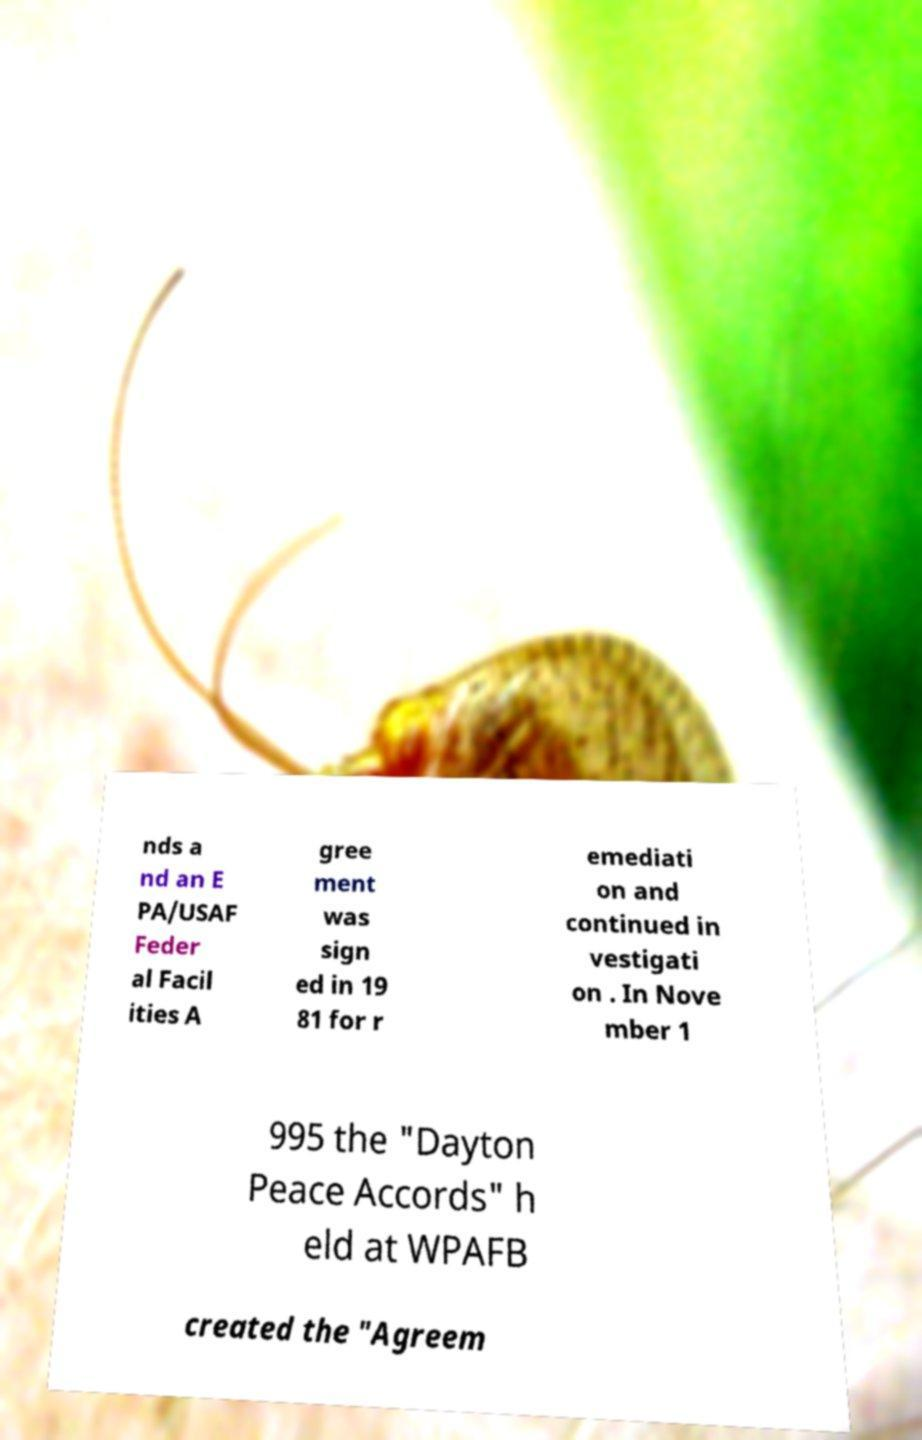Can you read and provide the text displayed in the image?This photo seems to have some interesting text. Can you extract and type it out for me? nds a nd an E PA/USAF Feder al Facil ities A gree ment was sign ed in 19 81 for r emediati on and continued in vestigati on . In Nove mber 1 995 the "Dayton Peace Accords" h eld at WPAFB created the "Agreem 